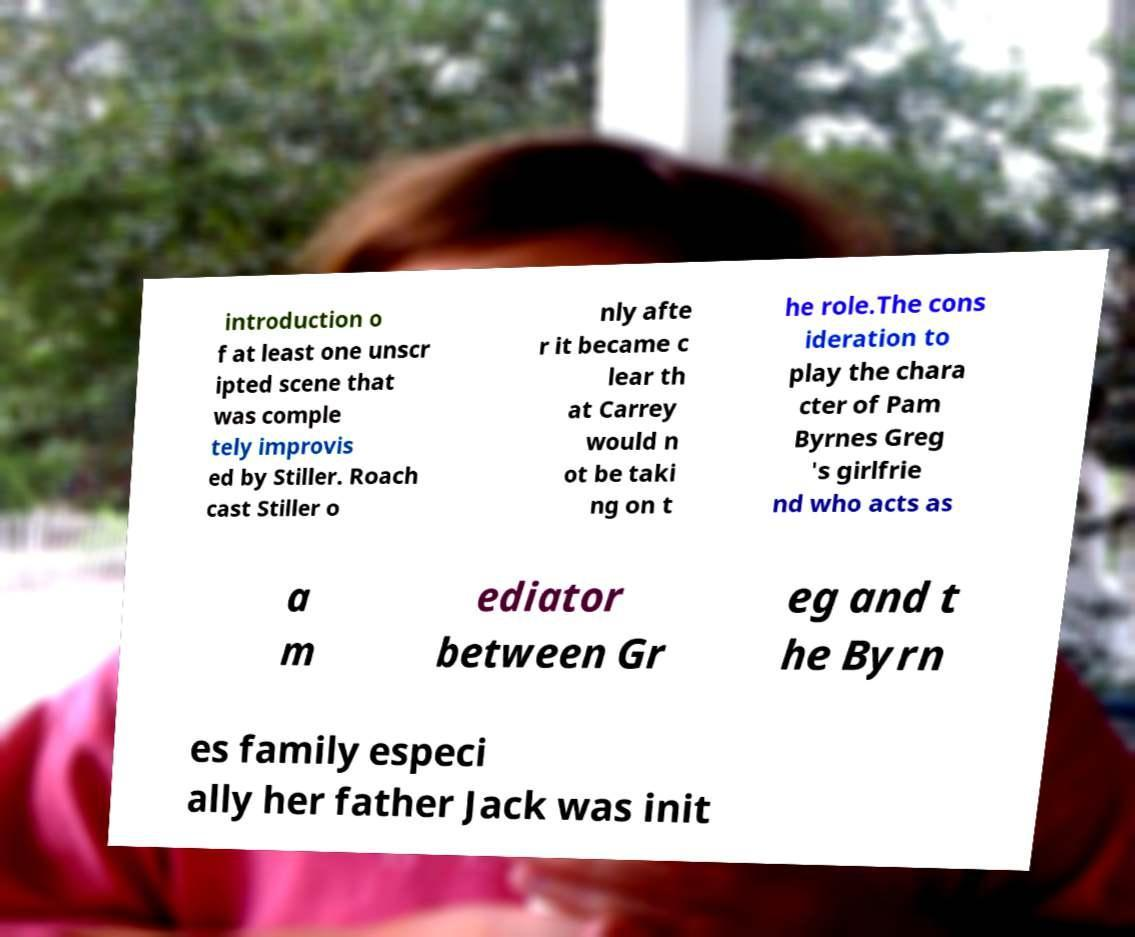For documentation purposes, I need the text within this image transcribed. Could you provide that? introduction o f at least one unscr ipted scene that was comple tely improvis ed by Stiller. Roach cast Stiller o nly afte r it became c lear th at Carrey would n ot be taki ng on t he role.The cons ideration to play the chara cter of Pam Byrnes Greg 's girlfrie nd who acts as a m ediator between Gr eg and t he Byrn es family especi ally her father Jack was init 